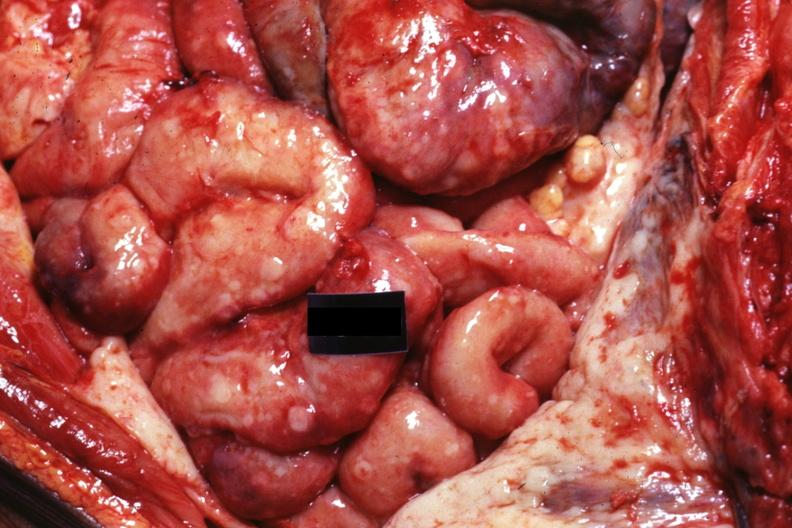does metastatic carcinoma prostate show in situ natural color very good?
Answer the question using a single word or phrase. No 